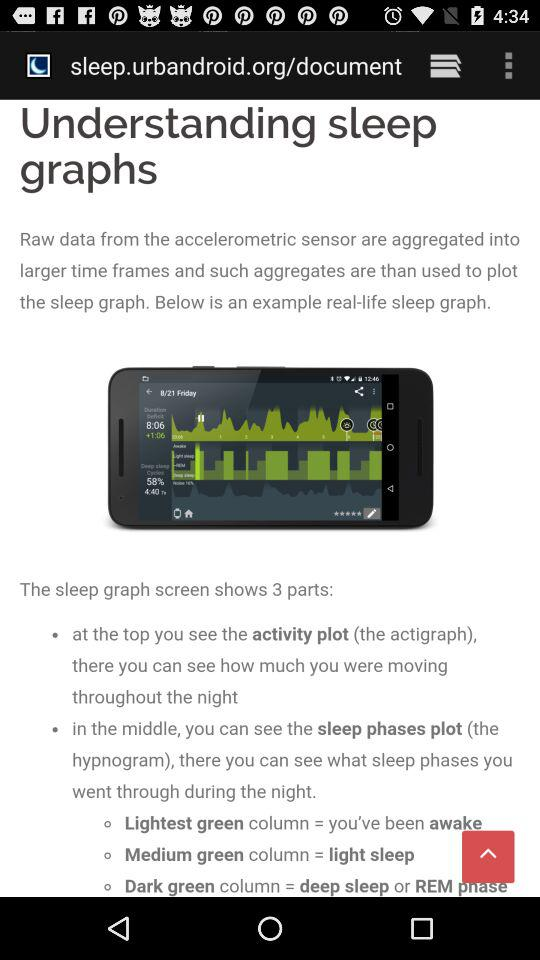Which column on the sleep graph screen represents light sleep? The column on the sleep graph screen that represents light sleep is "Medium green". 